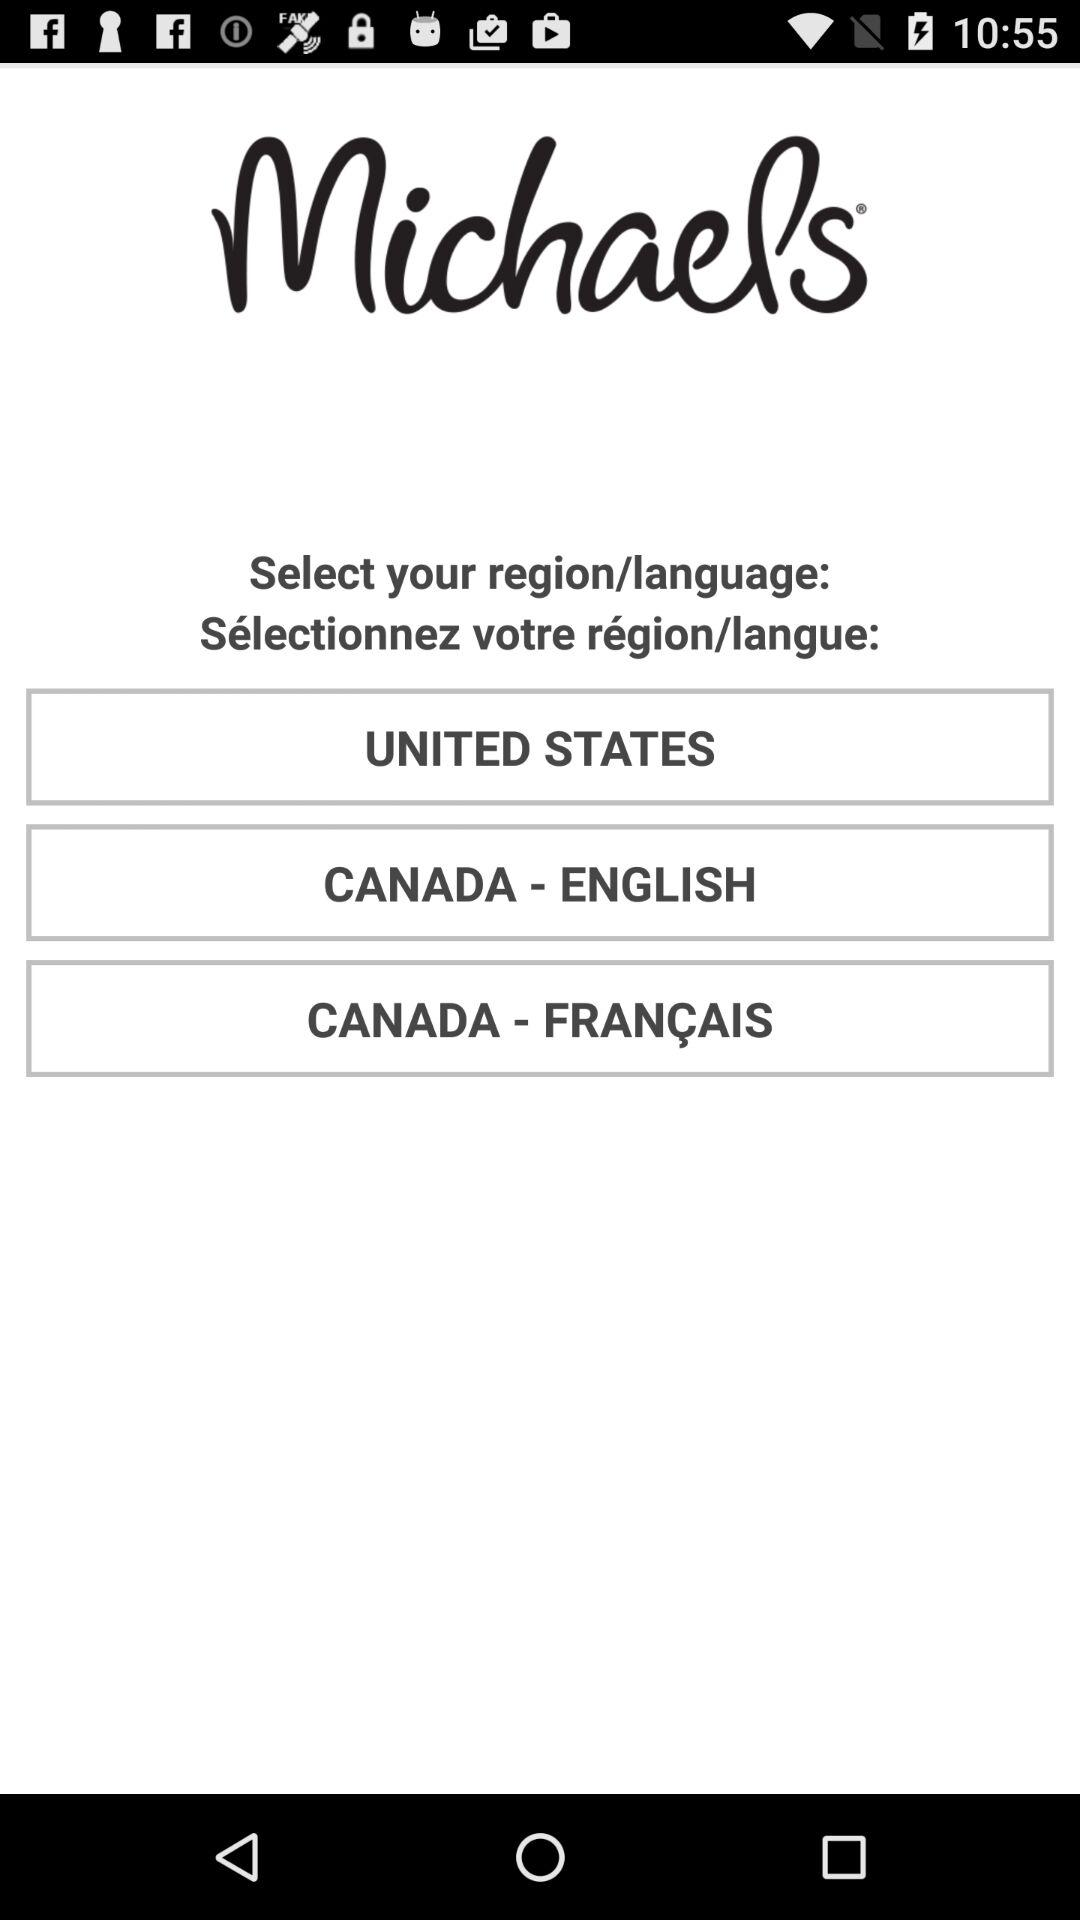What is the name of the application? The application name is "Michaels". 